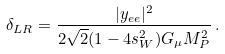Convert formula to latex. <formula><loc_0><loc_0><loc_500><loc_500>\delta _ { L R } = \frac { | y _ { e e } | ^ { 2 } } { 2 \sqrt { 2 } ( 1 - 4 s _ { W } ^ { 2 } ) G _ { \mu } M _ { P } ^ { 2 } } \, .</formula> 